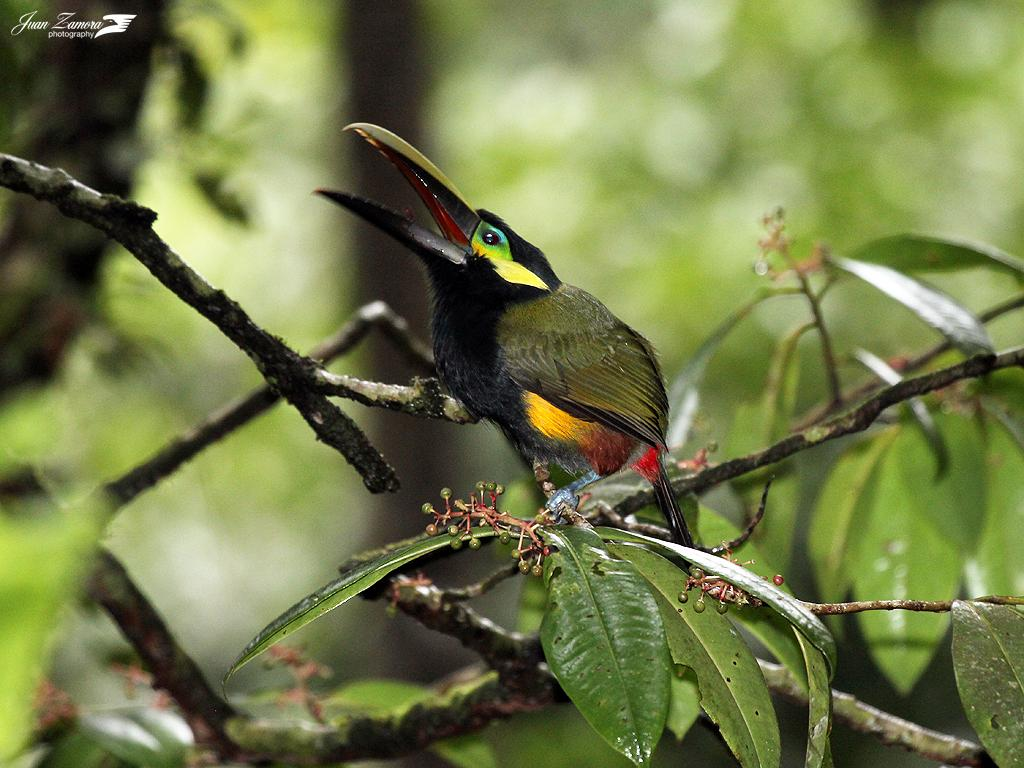What type of animal can be seen in the image? There is a bird in the image. Where is the bird located? The bird is on a branch of a tree. Can you describe the background of the image? The background of the image is blurry. What type of stamp is the bird holding in the image? There is no stamp present in the image, and the bird is not holding anything. 